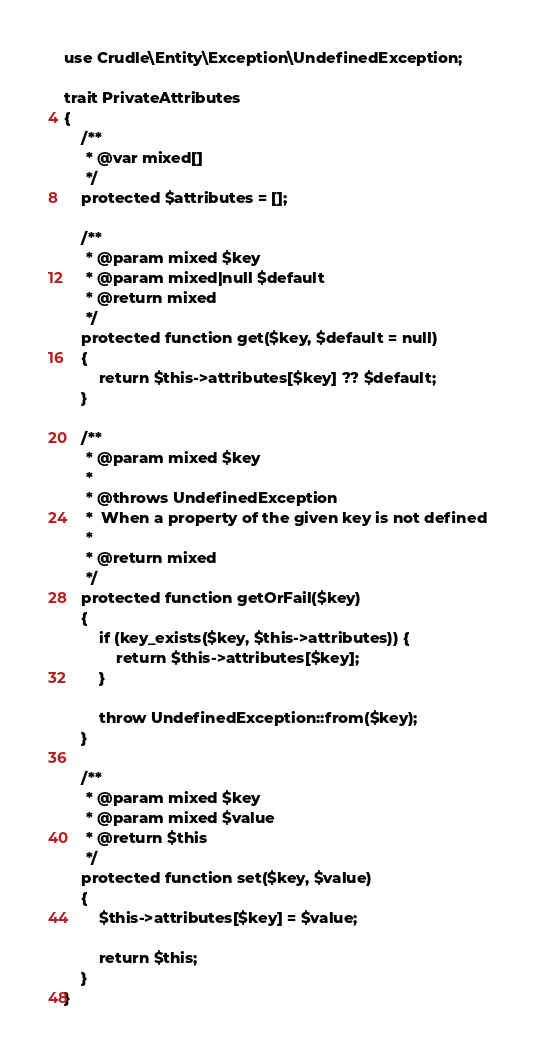<code> <loc_0><loc_0><loc_500><loc_500><_PHP_>use Crudle\Entity\Exception\UndefinedException;

trait PrivateAttributes
{
    /**
     * @var mixed[]
     */
    protected $attributes = [];

    /**
     * @param mixed $key
     * @param mixed|null $default
     * @return mixed
     */
    protected function get($key, $default = null)
    {
        return $this->attributes[$key] ?? $default;
    }

    /**
     * @param mixed $key
     *
     * @throws UndefinedException
     *  When a property of the given key is not defined
     *
     * @return mixed
     */
    protected function getOrFail($key)
    {
        if (key_exists($key, $this->attributes)) {
            return $this->attributes[$key];
        }

        throw UndefinedException::from($key);
    }

    /**
     * @param mixed $key
     * @param mixed $value
     * @return $this
     */
    protected function set($key, $value)
    {
        $this->attributes[$key] = $value;

        return $this;
    }
}
</code> 